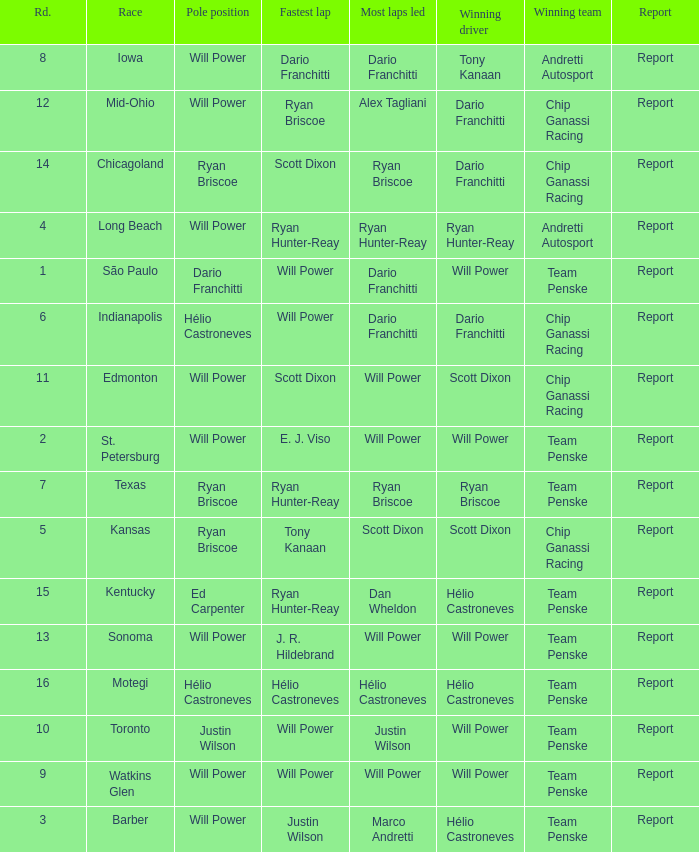Parse the table in full. {'header': ['Rd.', 'Race', 'Pole position', 'Fastest lap', 'Most laps led', 'Winning driver', 'Winning team', 'Report'], 'rows': [['8', 'Iowa', 'Will Power', 'Dario Franchitti', 'Dario Franchitti', 'Tony Kanaan', 'Andretti Autosport', 'Report'], ['12', 'Mid-Ohio', 'Will Power', 'Ryan Briscoe', 'Alex Tagliani', 'Dario Franchitti', 'Chip Ganassi Racing', 'Report'], ['14', 'Chicagoland', 'Ryan Briscoe', 'Scott Dixon', 'Ryan Briscoe', 'Dario Franchitti', 'Chip Ganassi Racing', 'Report'], ['4', 'Long Beach', 'Will Power', 'Ryan Hunter-Reay', 'Ryan Hunter-Reay', 'Ryan Hunter-Reay', 'Andretti Autosport', 'Report'], ['1', 'São Paulo', 'Dario Franchitti', 'Will Power', 'Dario Franchitti', 'Will Power', 'Team Penske', 'Report'], ['6', 'Indianapolis', 'Hélio Castroneves', 'Will Power', 'Dario Franchitti', 'Dario Franchitti', 'Chip Ganassi Racing', 'Report'], ['11', 'Edmonton', 'Will Power', 'Scott Dixon', 'Will Power', 'Scott Dixon', 'Chip Ganassi Racing', 'Report'], ['2', 'St. Petersburg', 'Will Power', 'E. J. Viso', 'Will Power', 'Will Power', 'Team Penske', 'Report'], ['7', 'Texas', 'Ryan Briscoe', 'Ryan Hunter-Reay', 'Ryan Briscoe', 'Ryan Briscoe', 'Team Penske', 'Report'], ['5', 'Kansas', 'Ryan Briscoe', 'Tony Kanaan', 'Scott Dixon', 'Scott Dixon', 'Chip Ganassi Racing', 'Report'], ['15', 'Kentucky', 'Ed Carpenter', 'Ryan Hunter-Reay', 'Dan Wheldon', 'Hélio Castroneves', 'Team Penske', 'Report'], ['13', 'Sonoma', 'Will Power', 'J. R. Hildebrand', 'Will Power', 'Will Power', 'Team Penske', 'Report'], ['16', 'Motegi', 'Hélio Castroneves', 'Hélio Castroneves', 'Hélio Castroneves', 'Hélio Castroneves', 'Team Penske', 'Report'], ['10', 'Toronto', 'Justin Wilson', 'Will Power', 'Justin Wilson', 'Will Power', 'Team Penske', 'Report'], ['9', 'Watkins Glen', 'Will Power', 'Will Power', 'Will Power', 'Will Power', 'Team Penske', 'Report'], ['3', 'Barber', 'Will Power', 'Justin Wilson', 'Marco Andretti', 'Hélio Castroneves', 'Team Penske', 'Report']]} Who was on the pole at Chicagoland? Ryan Briscoe. 